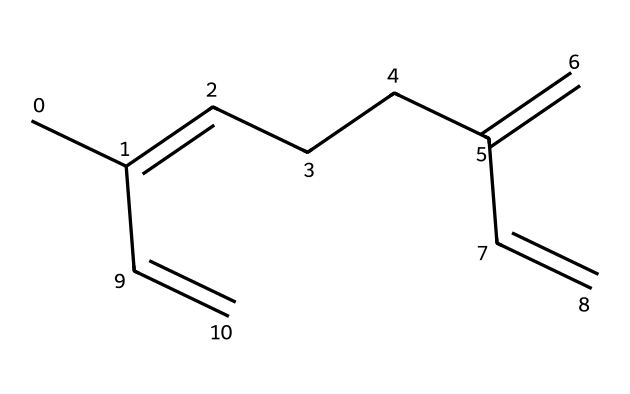What is the molecular formula of myrcene? To determine the molecular formula, count the number of carbon (C) and hydrogen (H) atoms in the chemical structure. The SMILES representation indicates 10 carbon atoms and 16 hydrogen atoms. Therefore, the molecular formula is C10H16.
Answer: C10H16 How many double bonds are present in myrcene? By analyzing the chemical structure via the SMILES, we can identify the instances of double bonds. There are three double bonds between carbon atoms in myrcene.
Answer: 3 What type of compound is myrcene classified as? Myrcene's structure, characterized as a terpene due to its isolated isoprene units, identifies it specifically as a monocyclic and acyclic terpene. Therefore, it is classified as a terpene.
Answer: terpene What is the total number of carbon atoms in myrcene? From the SMILES representation, we can easily count the number of "C" characters, which represents the carbon atoms. There are 10 carbon atoms present.
Answer: 10 What feature of myrcene contributes to its flavor profile in brewing? Myrcene has a specific configuration of double bonds and carbon structure that yields a citrusy and hoppy flavor, enhancing the overall sensory experience in beer. This is due to its unique aromatic properties as a terpene.
Answer: aromatic properties How many hydrogens does myrcene contain? The hydrogen count can be derived from the molecular formula or inferred from the structure. Since myrcene has a formula of C10H16, it indicates there are 16 hydrogen atoms.
Answer: 16 